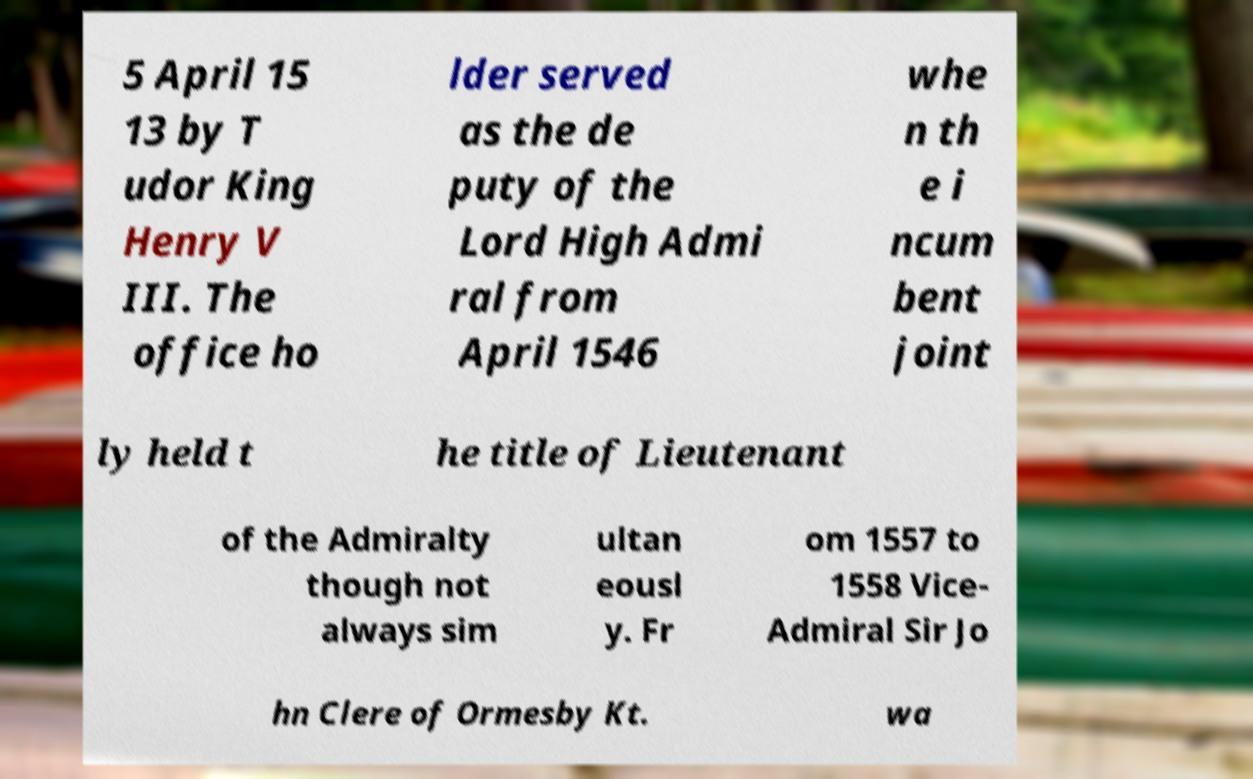For documentation purposes, I need the text within this image transcribed. Could you provide that? 5 April 15 13 by T udor King Henry V III. The office ho lder served as the de puty of the Lord High Admi ral from April 1546 whe n th e i ncum bent joint ly held t he title of Lieutenant of the Admiralty though not always sim ultan eousl y. Fr om 1557 to 1558 Vice- Admiral Sir Jo hn Clere of Ormesby Kt. wa 